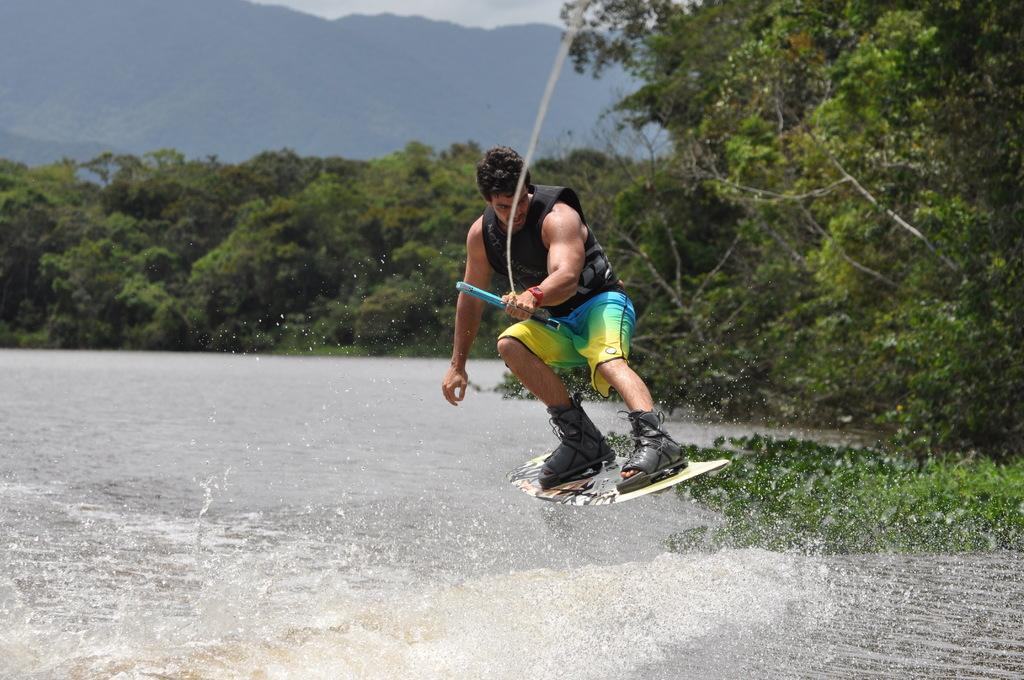What is the man in the image holding? The man is holding a surfboard and a rope. What is the man standing near in the image? There is water visible in the image, which suggests the man might be near a body of water. What type of landscape can be seen in the image? There are trees, hills, and the sky visible in the image, indicating a natural landscape. What type of comb is the cow using to groom itself in the image? There is no cow or comb present in the image. How is the spade being used by the man in the image? There is no spade visible in the image; the man is holding a surfboard and a rope. 